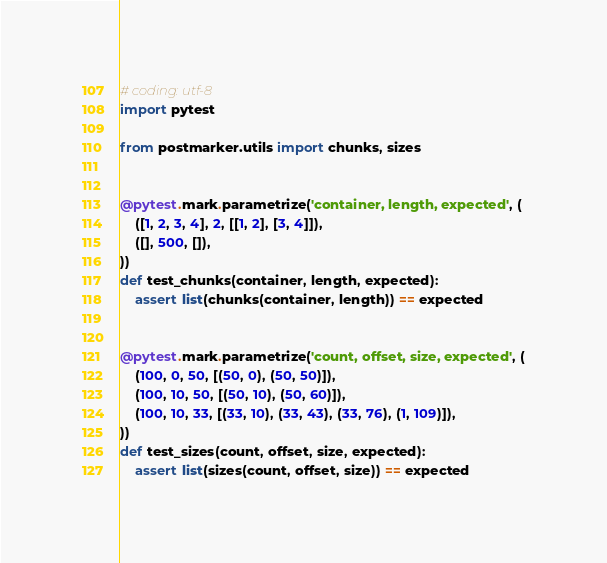<code> <loc_0><loc_0><loc_500><loc_500><_Python_># coding: utf-8
import pytest

from postmarker.utils import chunks, sizes


@pytest.mark.parametrize('container, length, expected', (
    ([1, 2, 3, 4], 2, [[1, 2], [3, 4]]),
    ([], 500, []),
))
def test_chunks(container, length, expected):
    assert list(chunks(container, length)) == expected


@pytest.mark.parametrize('count, offset, size, expected', (
    (100, 0, 50, [(50, 0), (50, 50)]),
    (100, 10, 50, [(50, 10), (50, 60)]),
    (100, 10, 33, [(33, 10), (33, 43), (33, 76), (1, 109)]),
))
def test_sizes(count, offset, size, expected):
    assert list(sizes(count, offset, size)) == expected
</code> 